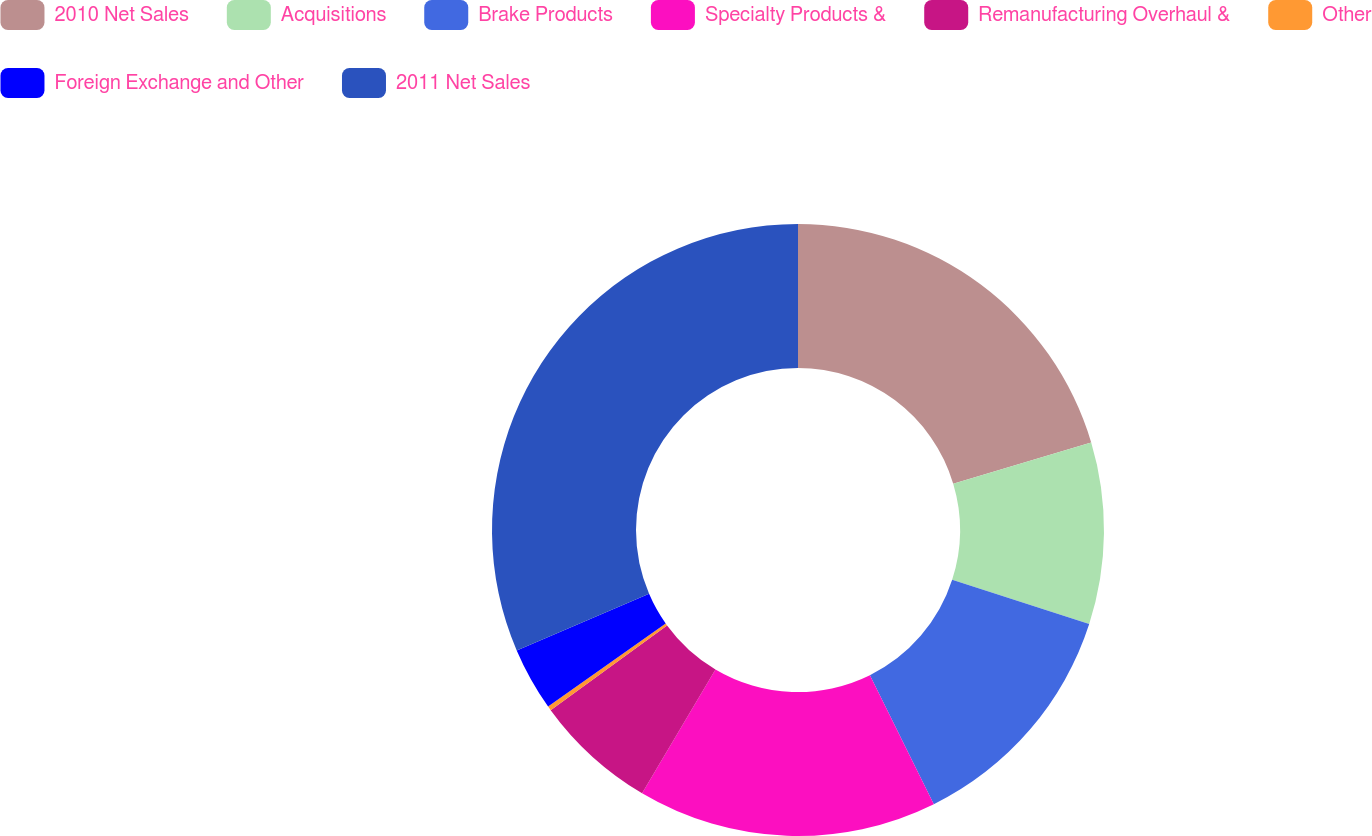Convert chart. <chart><loc_0><loc_0><loc_500><loc_500><pie_chart><fcel>2010 Net Sales<fcel>Acquisitions<fcel>Brake Products<fcel>Specialty Products &<fcel>Remanufacturing Overhaul &<fcel>Other<fcel>Foreign Exchange and Other<fcel>2011 Net Sales<nl><fcel>20.38%<fcel>9.59%<fcel>12.71%<fcel>15.83%<fcel>6.47%<fcel>0.23%<fcel>3.35%<fcel>31.44%<nl></chart> 